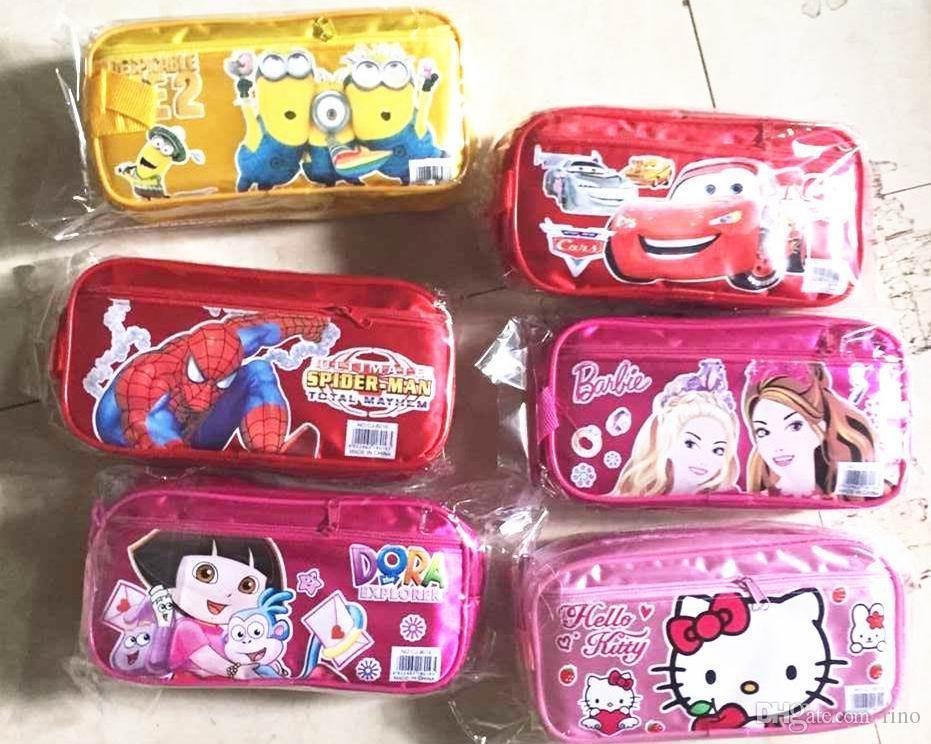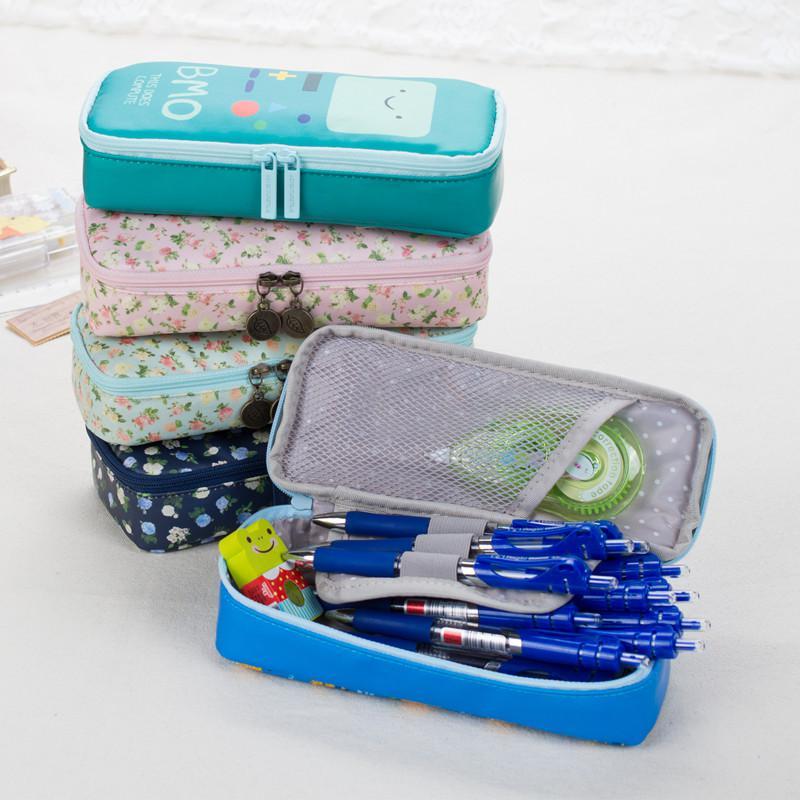The first image is the image on the left, the second image is the image on the right. For the images shown, is this caption "In one image, a wooden pencil case has a drawer pulled out to reveal stowed items and the top raised to show writing tools and a small blackboard with writing on it." true? Answer yes or no. No. The first image is the image on the left, the second image is the image on the right. For the images displayed, is the sentence "An image shows solid-color blue, pink, yellow and aqua zipper pencil cases, with three of them in a single row." factually correct? Answer yes or no. No. 